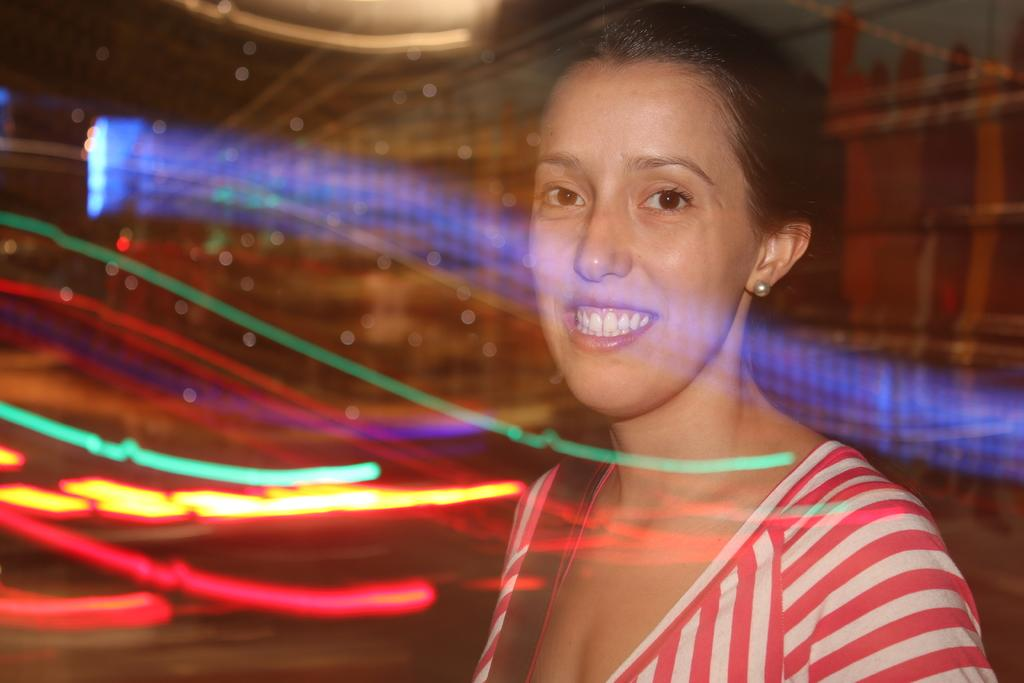What is the main subject of the image? There is a person in the image. Can you describe the person's attire? The person is wearing clothes. What can be observed about the background of the image? The background of the image is colorful. What type of rose is the person holding in the image? There is no rose present in the image; the person is not holding any object. 